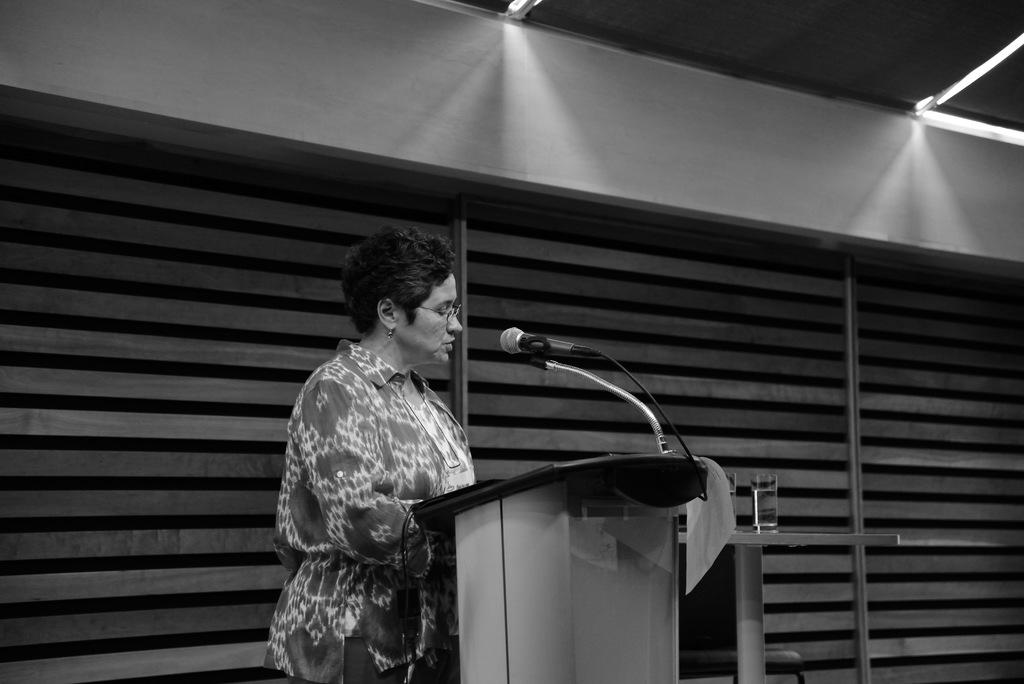What is the color scheme of the image? The image is black and white. What is the main subject of the image? There is a woman standing at a desk in the center of the image. What can be seen in the background of the image? There is a wall in the background of the image. How many shirts is the woman wearing in the image? The image is black and white, so it is not possible to determine the number of shirts the woman is wearing based on color. Additionally, the number of shirts is not mentioned in the provided facts. 